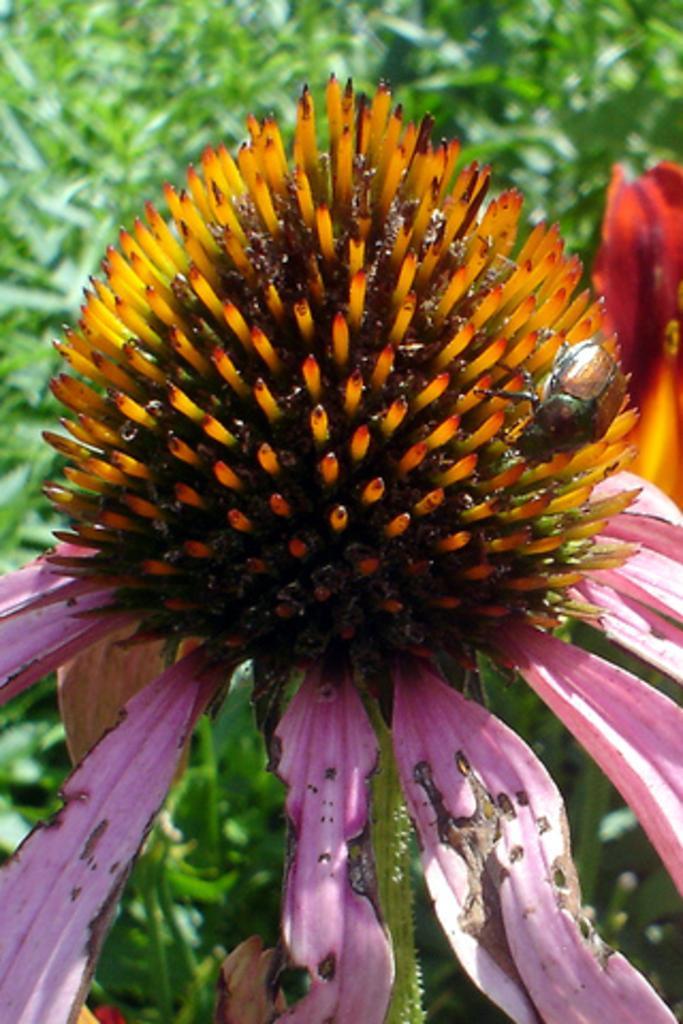In one or two sentences, can you explain what this image depicts? In this image I can see the flower to the plant. The flower is in orange and pink color. In the back I can see few more plants. 